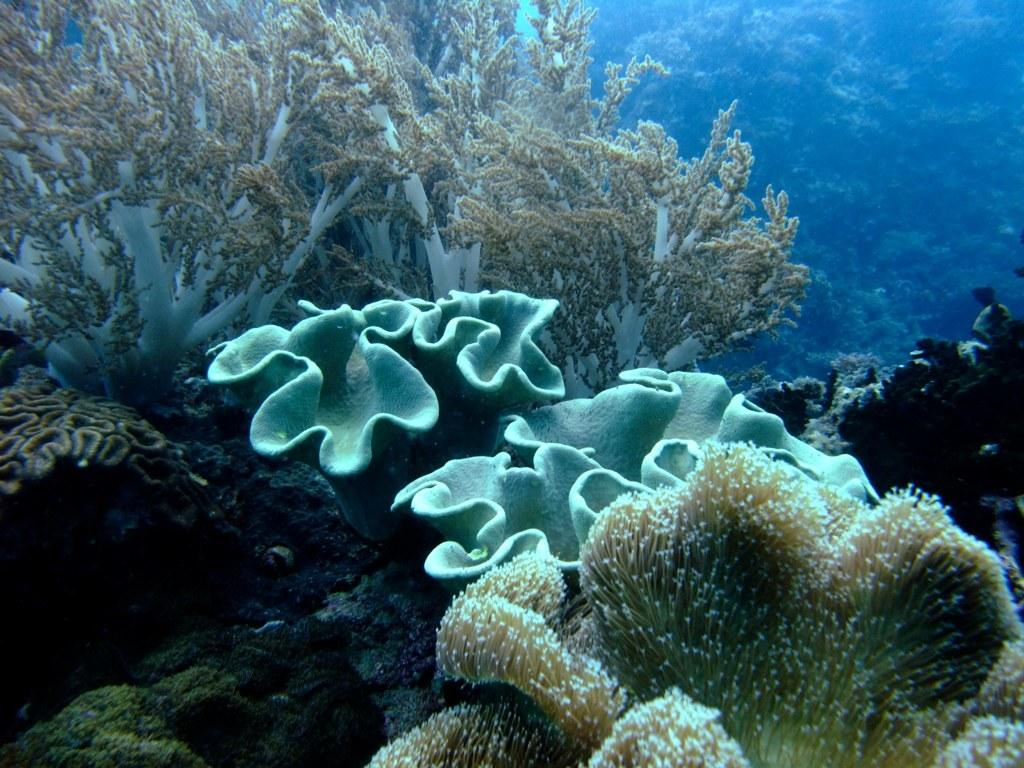What type of creatures are present in the image? There are underwater species in the picture. Can you describe the appearance of these creatures? The underwater species have different colors and shapes. What type of event is taking place in the image? There is no event present in the image; it features underwater species with different colors and shapes. Can you tell me how the underwater species are expressing anger in the image? There is no indication of anger or any emotions in the image; it simply shows underwater species with different colors and shapes. 